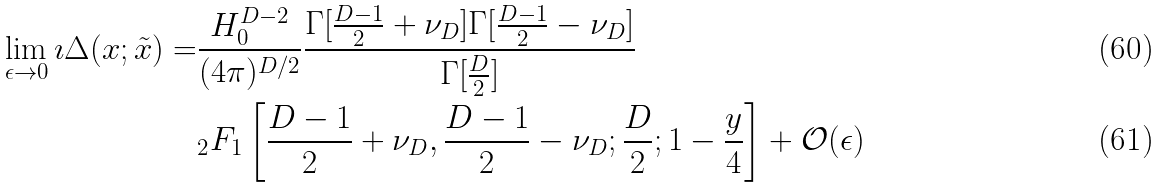<formula> <loc_0><loc_0><loc_500><loc_500>\lim _ { \epsilon \rightarrow 0 } { \imath \Delta ( x ; \tilde { x } ) } = & \frac { H _ { 0 } ^ { D - 2 } } { ( 4 \pi ) ^ { D / 2 } } \frac { \Gamma [ \frac { D - 1 } { 2 } + \nu _ { D } ] \Gamma [ \frac { D - 1 } { 2 } - \nu _ { D } ] } { \Gamma [ \frac { D } { 2 } ] } \\ & _ { 2 } F _ { 1 } \left [ \frac { D - 1 } { 2 } + \nu _ { D } , \frac { D - 1 } { 2 } - \nu _ { D } ; \frac { D } { 2 } ; 1 - \frac { y } { 4 } \right ] + \mathcal { O } ( \epsilon )</formula> 